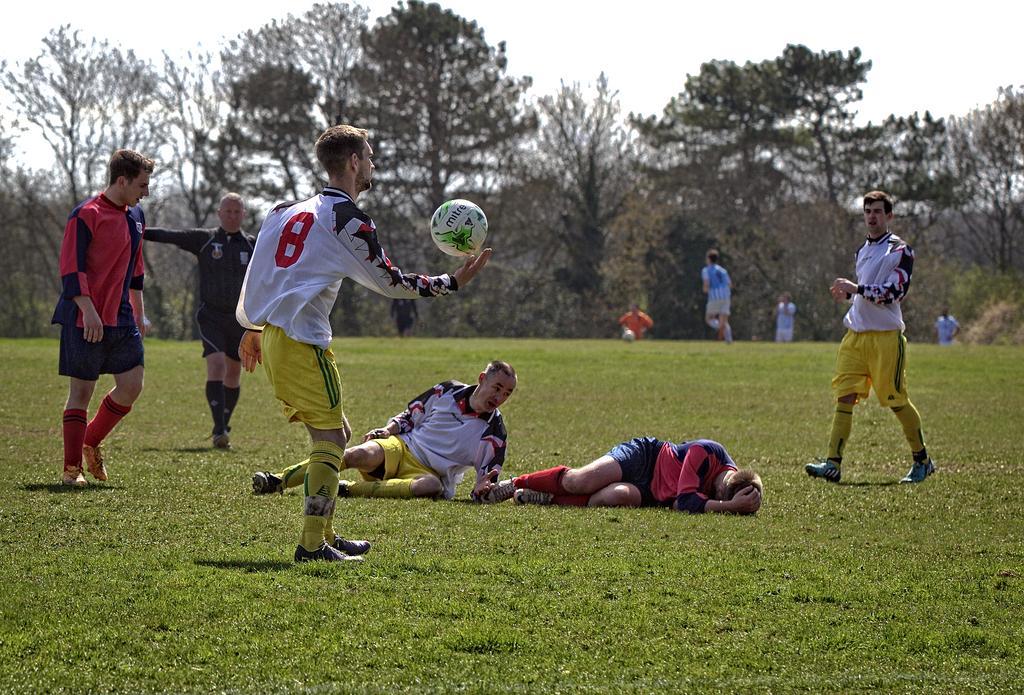Describe this image in one or two sentences. As we can see in the image there are few people here and there, white color football, grass and trees. On the top there is sky. 